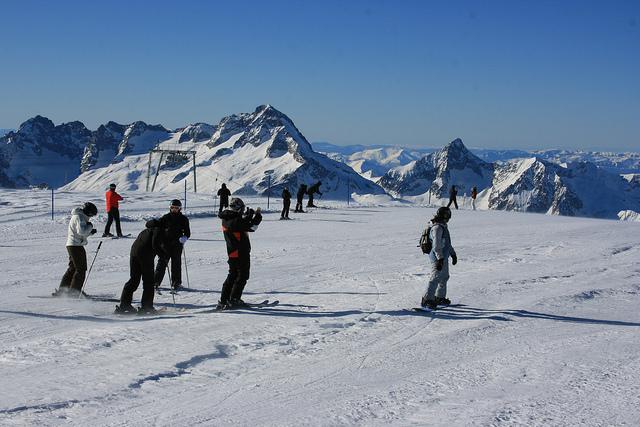Is there snow on the ground?
Answer briefly. Yes. Is the middle person wearing only one ski?
Answer briefly. No. Should they be worried about sunburn?
Answer briefly. No. Is it winter?
Short answer required. Yes. What number of men are standing near each other?
Give a very brief answer. 4. 